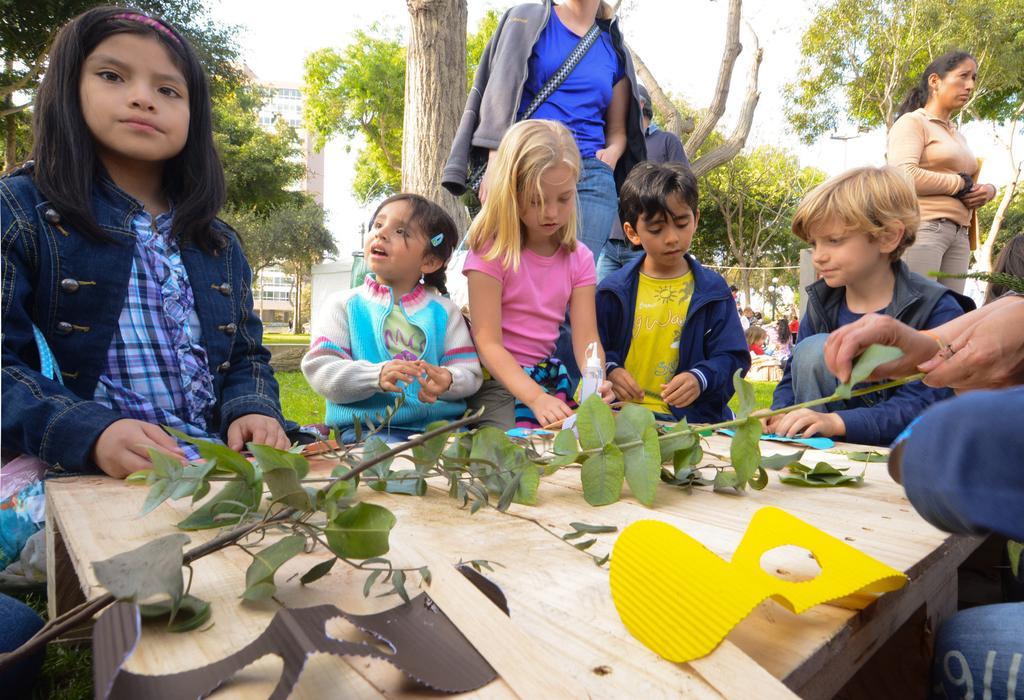Please provide a concise description of this image. In this image i can see a group of children in front of a table and two women. I can also see there is a building and a couple of buildings on the ground. On the table we have couple of objects on it. 